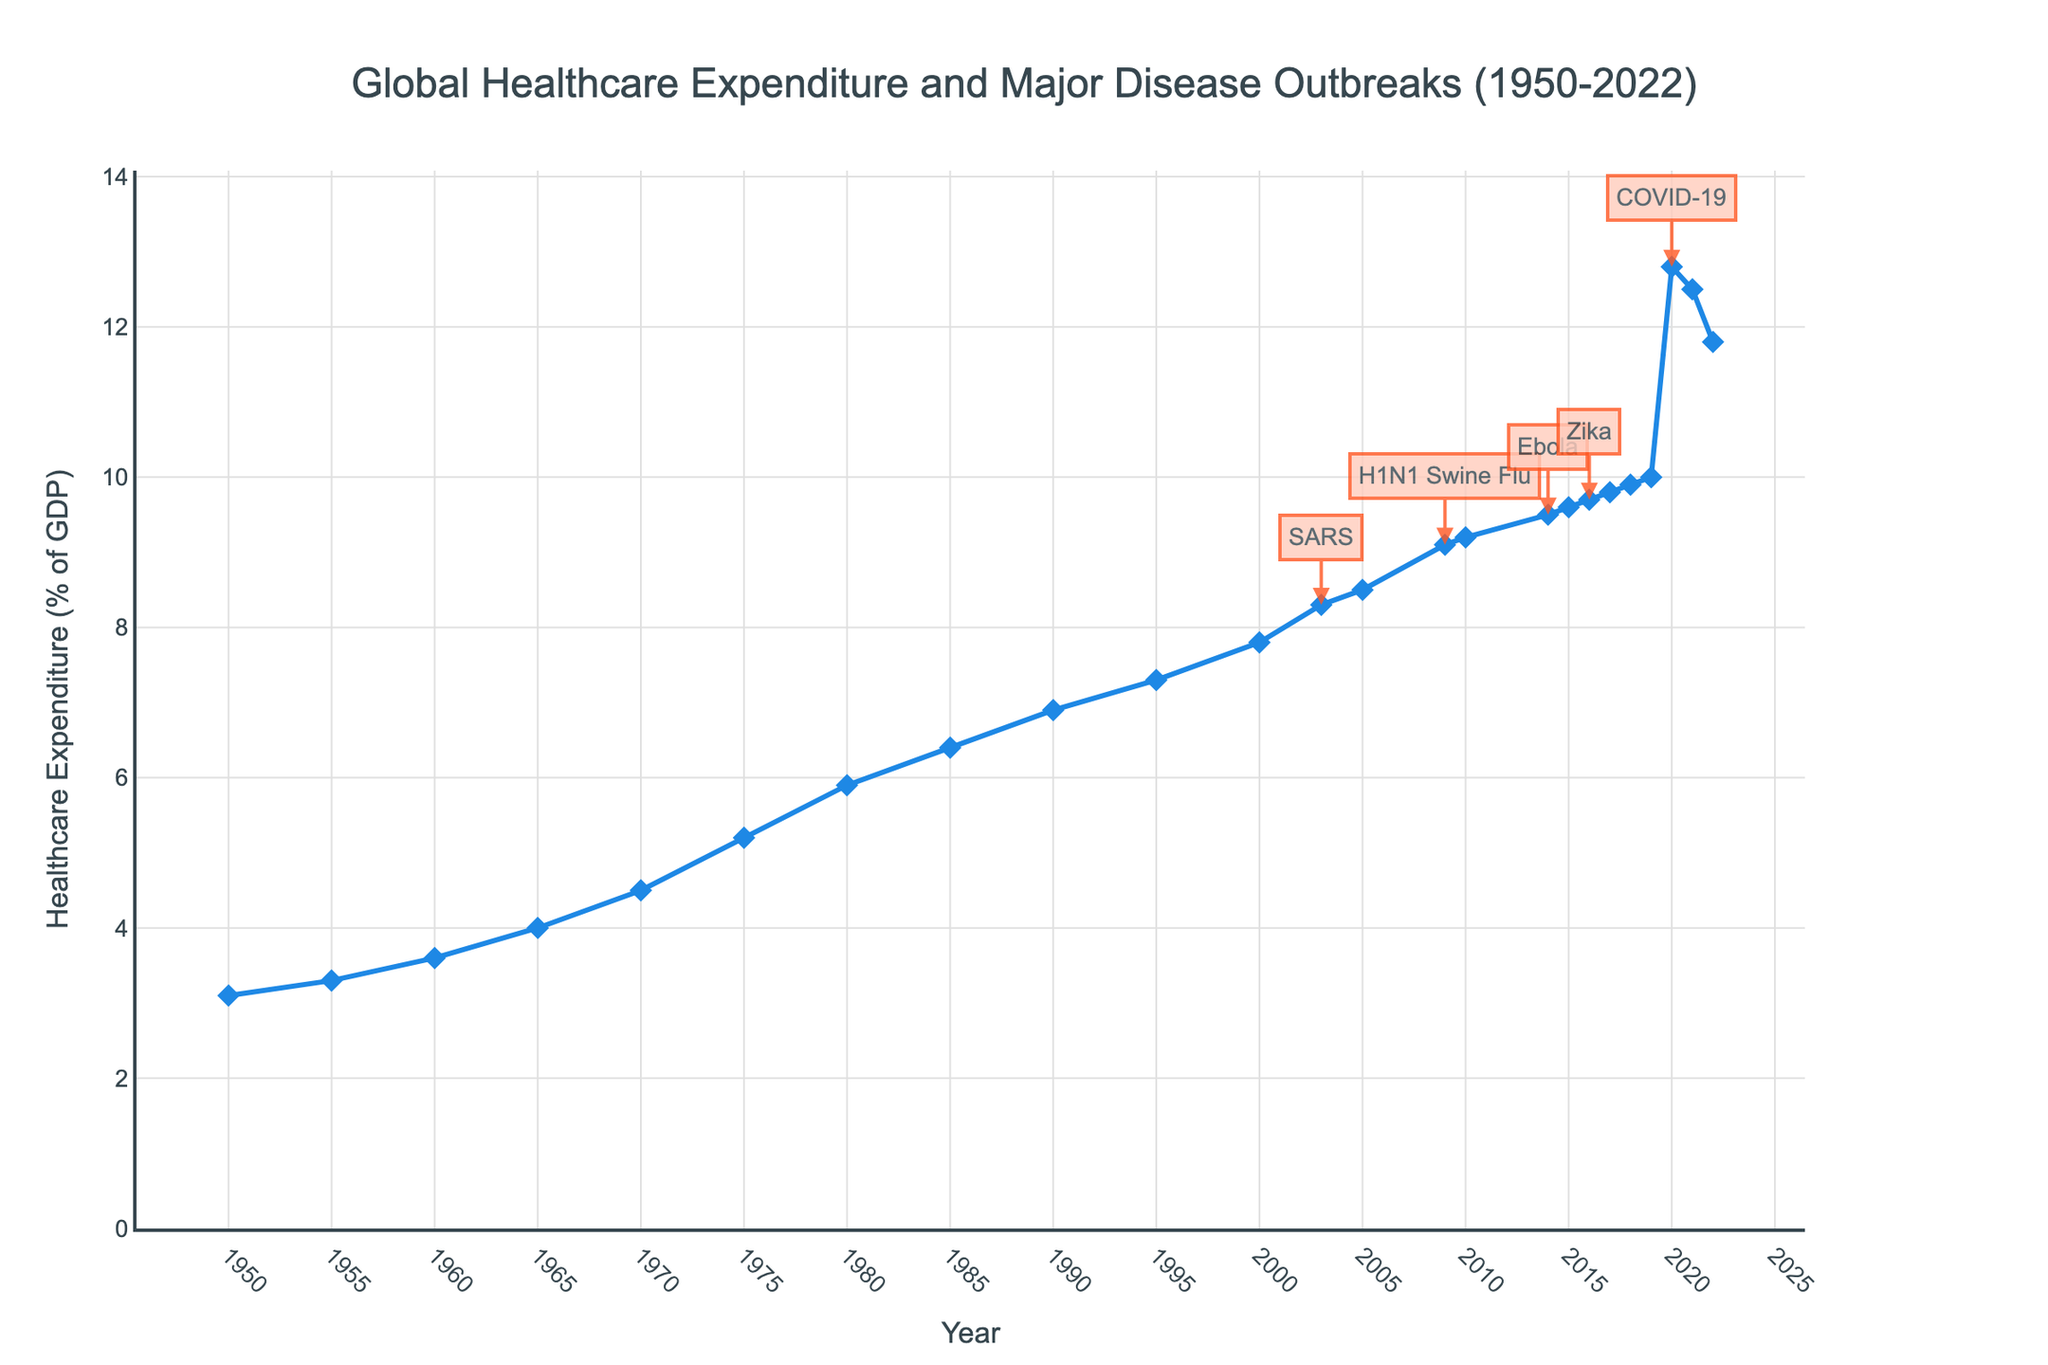What is the general trend of global healthcare expenditure as a percentage of GDP from 1950 to 2022? The figure shows that global healthcare expenditure as a percentage of GDP has been steadily increasing from 1950 to 2022, with noticeable spikes during certain years. This indicates a consistent upward trend in healthcare spending relative to GDP over the long term.
Answer: Increasing How did the COVID-19 outbreak in 2020 affect global healthcare expenditure as a percentage of GDP compared to 2019? From the figure, we can see that healthcare expenditure as a percentage of GDP significantly increased from 10.0% in 2019 to 12.8% in 2020. This indicates a substantial rise in healthcare spending during the COVID-19 outbreak.
Answer: Increased from 10.0% to 12.8% By how much did the healthcare expenditure as a percentage of GDP change from 2009 (H1N1 Swine Flu) to 2010? In 2009, healthcare expenditure was at 9.1%, and in 2010, it was at 9.2%. Calculating the difference gives us 9.2% - 9.1% = 0.1%.
Answer: 0.1% Which major disease outbreak is associated with the largest increase in healthcare expenditure as a percentage of GDP, and by how much did it increase? By examining the figure, we find that the largest increase is associated with the COVID-19 outbreak in 2020, where the expenditure increased from 10.0% in 2019 to 12.8% in 2020, an increase of 2.8%.
Answer: COVID-19, increased by 2.8% Compare the healthcare expenditure change during the Ebola outbreak in 2014 to the Zika outbreak in 2016. Which year had a higher increase, and what are the respective increases? In 2014, the expenditure increased from 9.2% in 2010 to 9.5% in 2014. During the Zika outbreak in 2016, the expenditure increased from 9.6% in 2015 to 9.7% in 2016. Thus, the increase in 2014 was 0.3%, and the increase in 2016 was 0.1%. 2014 had a higher increase.
Answer: 2014, 0.3% What is the average healthcare expenditure as a percentage of GDP during the five-year periods before and after the SARS outbreak in 2003? Calculating the average for the periods 1998-2002 (before SARS): (7.8+8.3)/5 = 8.3%. For 2004-2008 (after SARS): (8.5+9.1)/5 = 8.7%.
Answer: Before SARS: 8.0%, After SARS: 8.8% Which year had the highest healthcare expenditure as a percentage of GDP, and what major disease outbreak occurred during that time? The figure shows that the highest healthcare expenditure as a percentage of GDP occurred in 2020, reaching 12.8%, during the COVID-19 outbreak.
Answer: 2020, COVID-19 How did global healthcare expenditure as a percentage of GDP trend between the two significant outbreaks of 2003 (SARS) and 2009 (H1N1 Swine Flu)? From the figure, the healthcare expenditure increased steadily from 8.3% in 2003 (SARS) to 9.1% in 2009 (H1N1 Swine Flu). This indicates a gradual upward trend during this period.
Answer: Increased from 8.3% to 9.1% What was the percentage difference in global healthcare expenditure between 1980 and 2022? In 1980, the expenditure was 5.9%, and in 2022, it was 11.8%. Calculating the difference gives us 11.8% - 5.9% = 5.9%.
Answer: 5.9% What is the overall percentage increase in healthcare expenditure as a percentage of GDP from 1950 to 2022? In 1950, the expenditure was 3.1%, and in 2022, it was 11.8%. The increase is calculated as (11.8% - 3.1%)/3.1% * 100 = approximately 280.6%.
Answer: Approximately 280.6% 